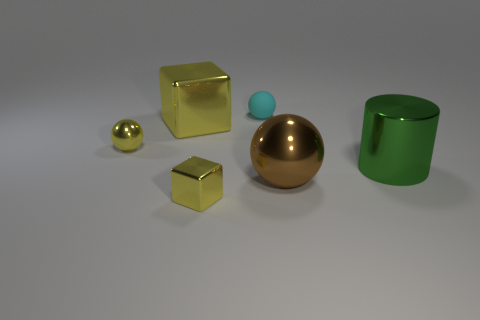Add 3 small yellow cubes. How many objects exist? 9 Subtract all small spheres. How many spheres are left? 1 Subtract all blocks. How many objects are left? 4 Subtract 1 cylinders. How many cylinders are left? 0 Add 6 tiny cyan metallic objects. How many tiny cyan metallic objects exist? 6 Subtract all cyan balls. How many balls are left? 2 Subtract 1 brown spheres. How many objects are left? 5 Subtract all brown cylinders. Subtract all cyan blocks. How many cylinders are left? 1 Subtract all purple shiny balls. Subtract all big metallic cubes. How many objects are left? 5 Add 6 cylinders. How many cylinders are left? 7 